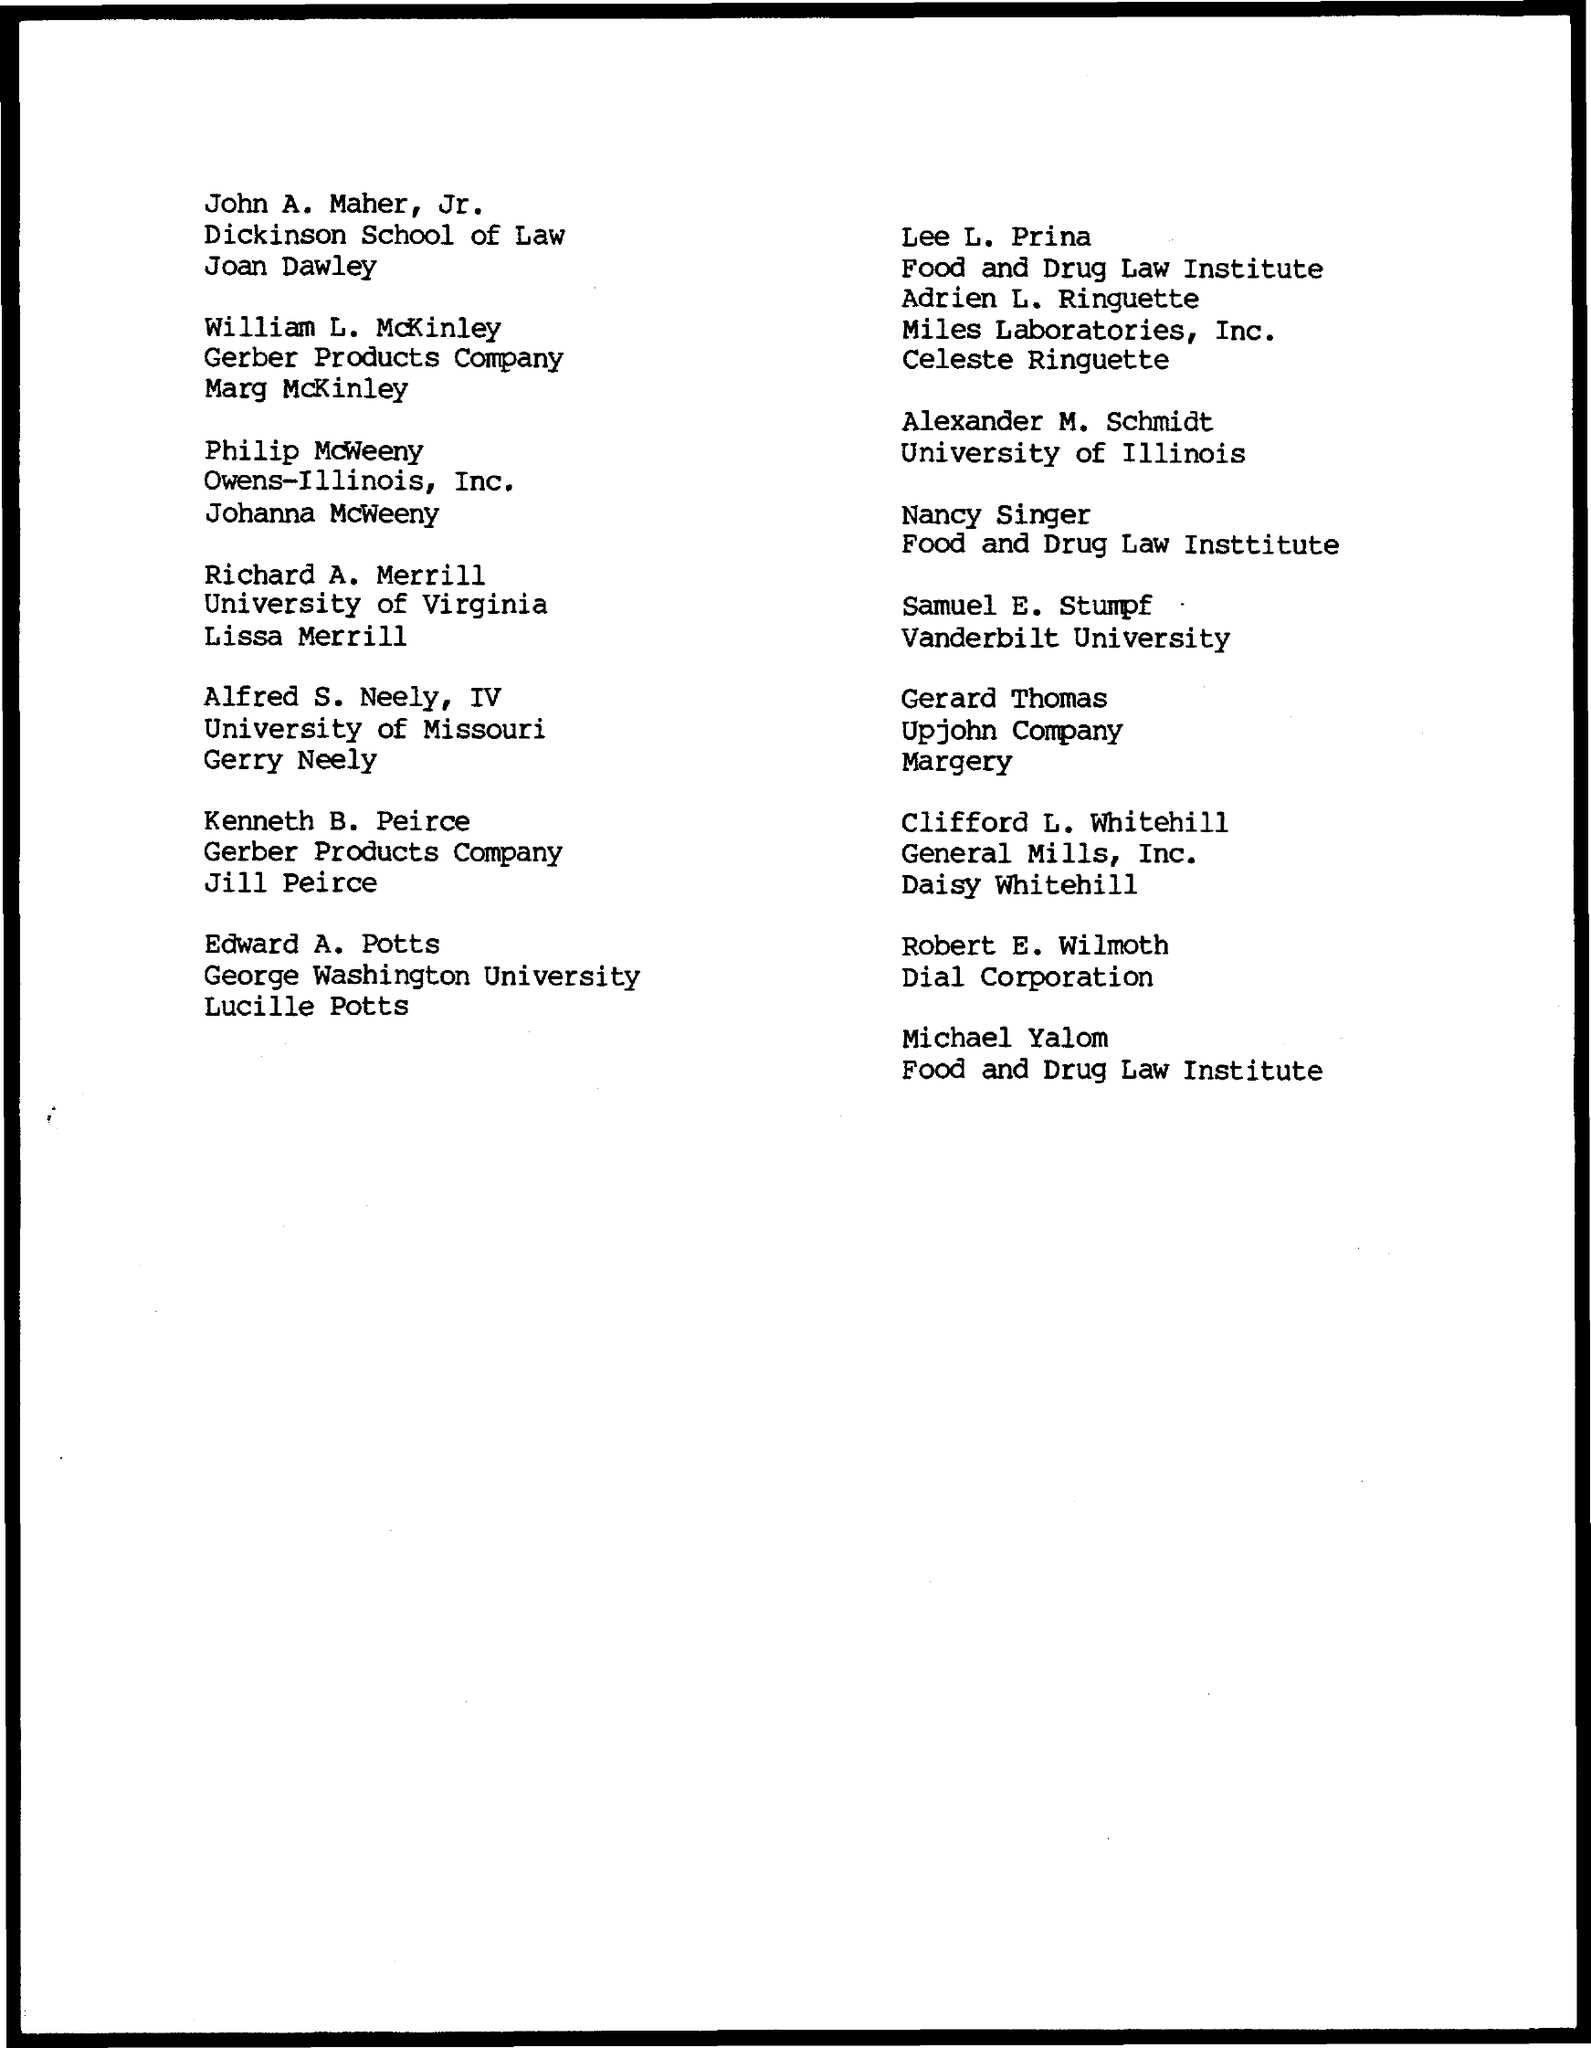Who is a member of the dial corporation?
Your response must be concise. Robert E. Wilmoth. Who is a member of the Upjohn Company?
Your response must be concise. Gerard Thomas. Who is a member of the Vanderbilt University?
Your answer should be compact. Samuel E. Stumpf. Who is a member of the University of Illinois?
Give a very brief answer. Alexander M. Schmidt. 